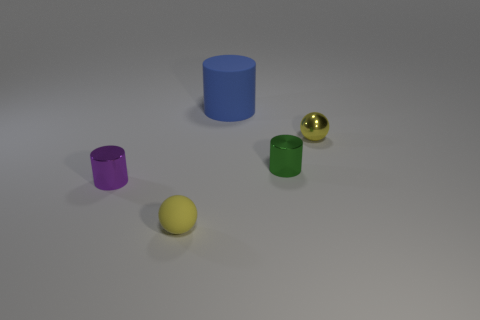Are there any other things that are the same size as the rubber cylinder?
Your response must be concise. No. Do the tiny metal ball and the sphere to the left of the big rubber cylinder have the same color?
Provide a short and direct response. Yes. What is the material of the ball that is left of the tiny ball that is behind the small metallic object that is on the left side of the blue thing?
Your answer should be compact. Rubber. What is the thing that is both behind the green shiny cylinder and on the left side of the small green thing made of?
Provide a short and direct response. Rubber. What number of yellow rubber things are the same shape as the big blue matte object?
Offer a terse response. 0. How big is the matte object on the right side of the matte object that is in front of the large blue cylinder?
Provide a succinct answer. Large. Is the color of the small ball that is to the left of the small yellow metallic ball the same as the tiny ball that is right of the big blue matte thing?
Provide a short and direct response. Yes. What number of small cylinders are to the left of the large blue matte cylinder that is right of the object that is in front of the purple shiny object?
Your answer should be very brief. 1. What number of things are on the left side of the rubber cylinder and behind the yellow matte ball?
Keep it short and to the point. 1. Is the number of tiny yellow spheres in front of the purple thing greater than the number of tiny cyan balls?
Keep it short and to the point. Yes. 